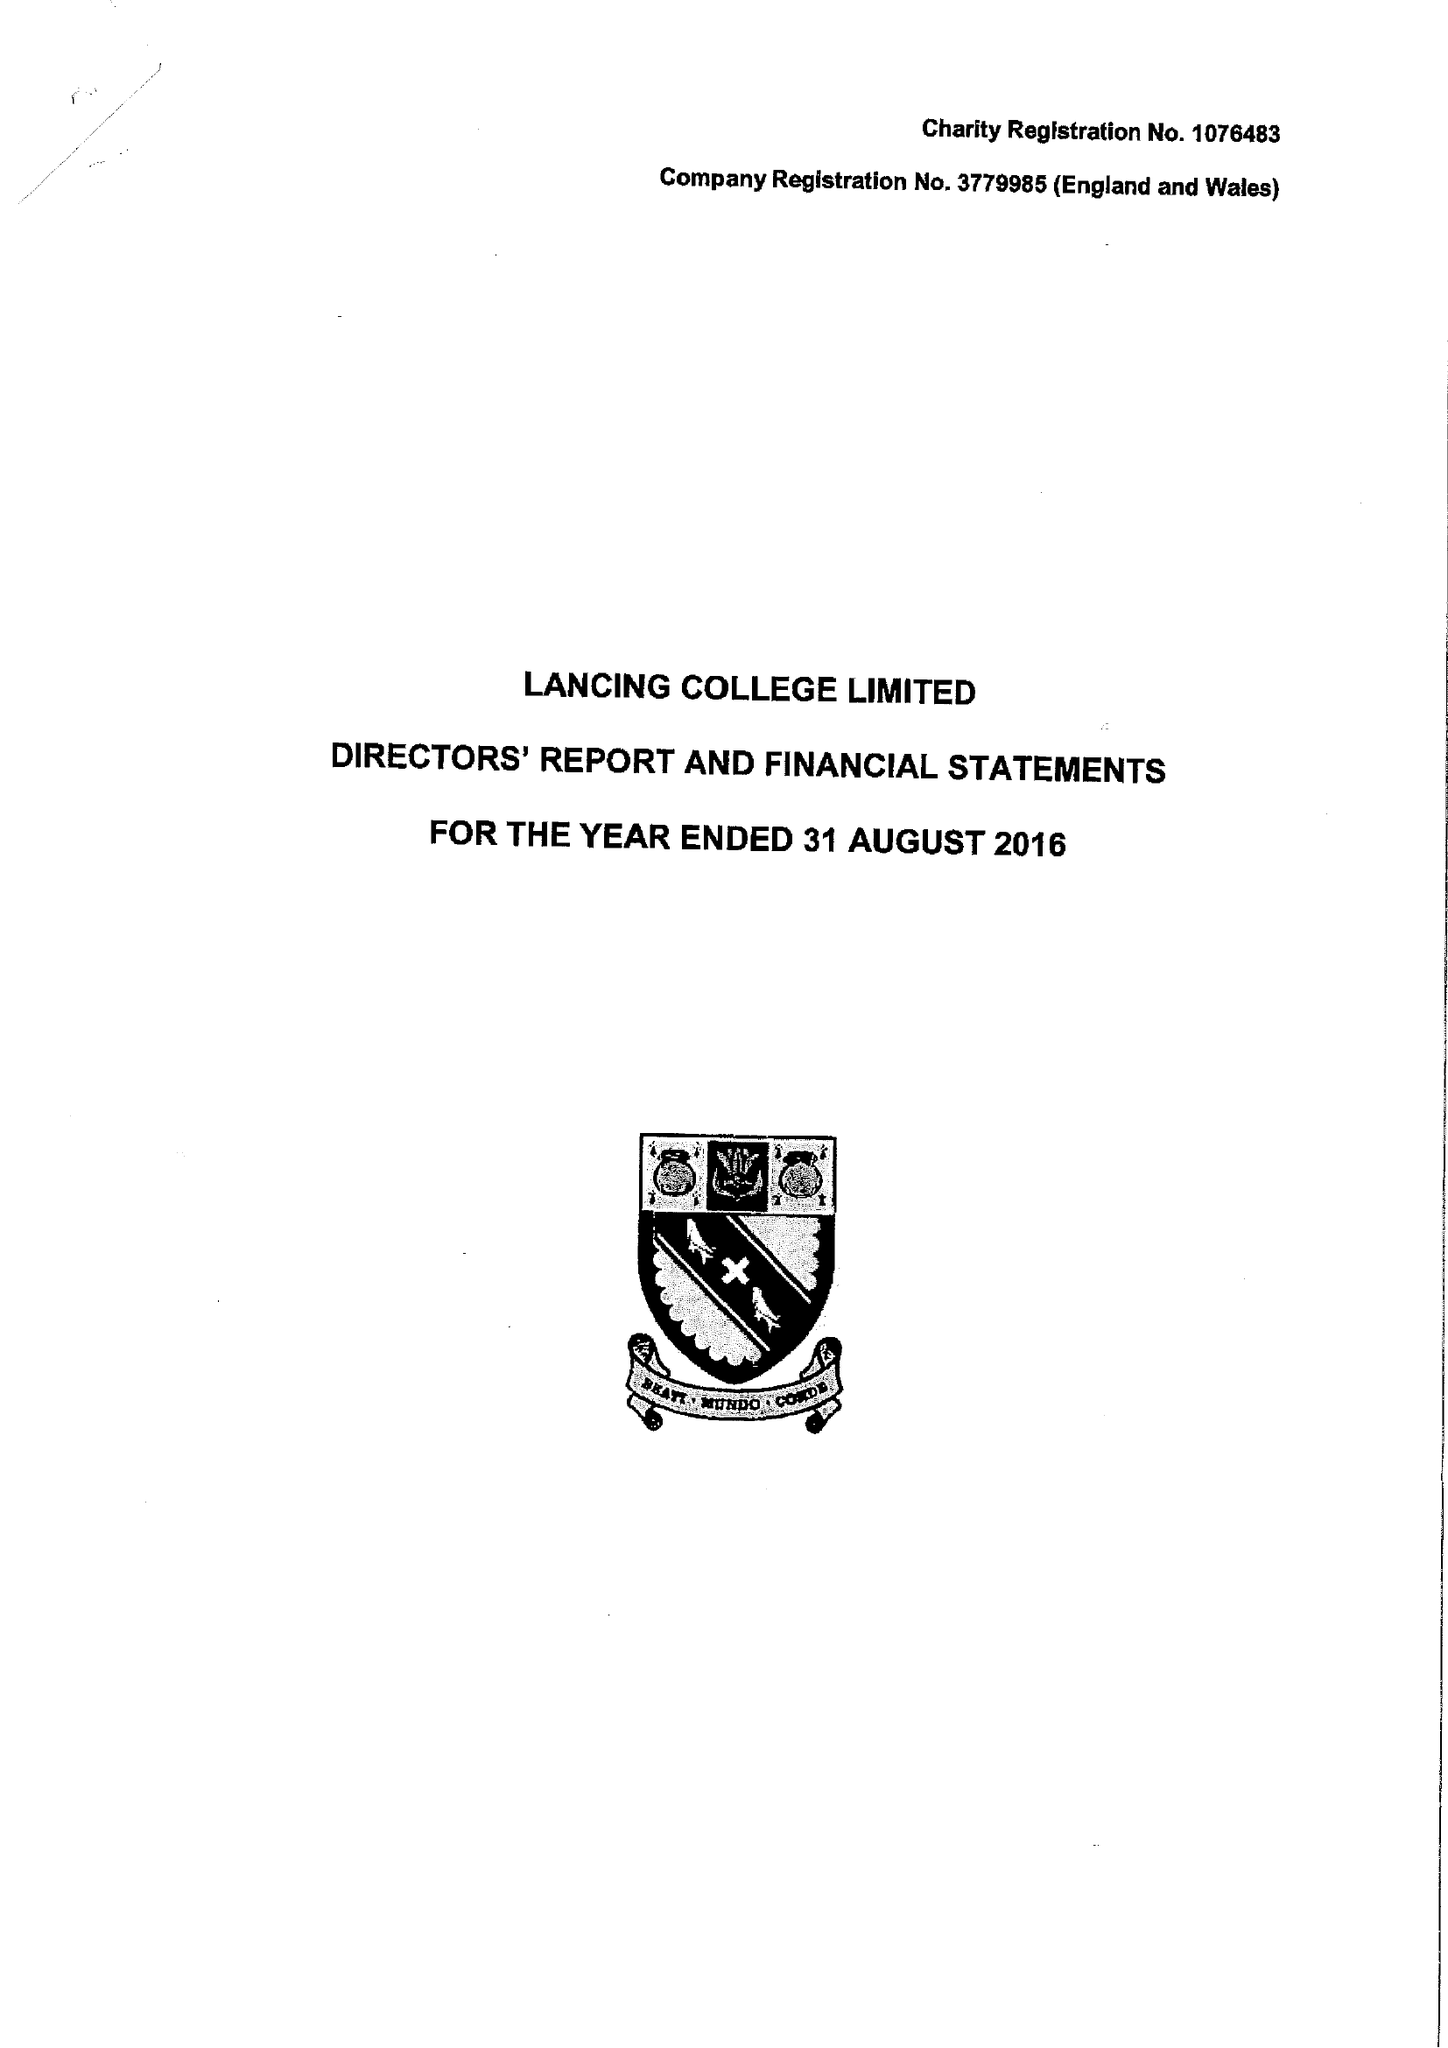What is the value for the charity_name?
Answer the question using a single word or phrase. Lancing College Ltd. 